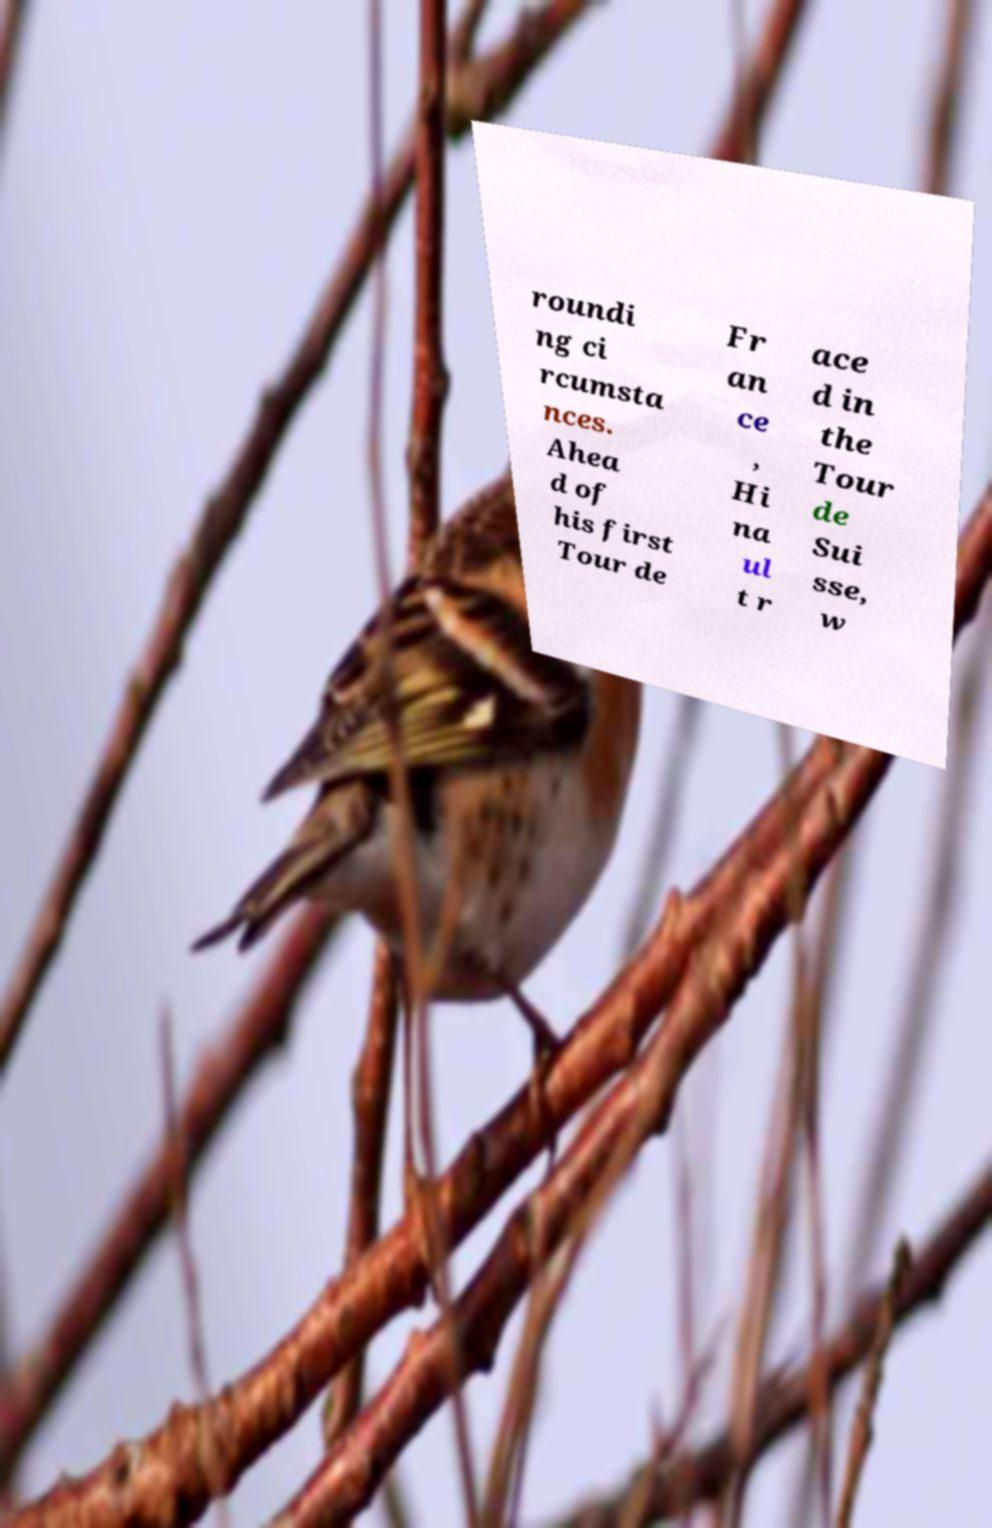Can you read and provide the text displayed in the image?This photo seems to have some interesting text. Can you extract and type it out for me? roundi ng ci rcumsta nces. Ahea d of his first Tour de Fr an ce , Hi na ul t r ace d in the Tour de Sui sse, w 